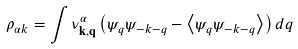<formula> <loc_0><loc_0><loc_500><loc_500>\rho _ { \alpha k } = \int \nu _ { \mathbf k , \mathbf q } ^ { \alpha } \left ( \psi _ { q } \psi _ { - k - q } - \left < \psi _ { q } \psi _ { - k - q } \right > \right ) d q</formula> 